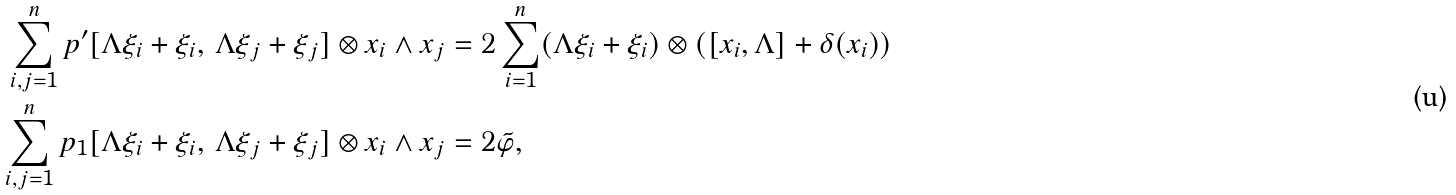Convert formula to latex. <formula><loc_0><loc_0><loc_500><loc_500>\sum _ { i , j = 1 } ^ { n } p ^ { \prime } [ \Lambda \xi _ { i } + \xi _ { i } , \, \Lambda \xi _ { j } + \xi _ { j } ] \otimes x _ { i } \wedge x _ { j } & = 2 \sum _ { i = 1 } ^ { n } ( \Lambda \xi _ { i } + \xi _ { i } ) \otimes ( [ x _ { i } , \Lambda ] + \delta ( x _ { i } ) ) \\ \sum _ { i , j = 1 } ^ { n } p _ { 1 } [ \Lambda \xi _ { i } + \xi _ { i } , \, \Lambda \xi _ { j } + \xi _ { j } ] \otimes x _ { i } \wedge x _ { j } & = 2 \tilde { \varphi } ,</formula> 